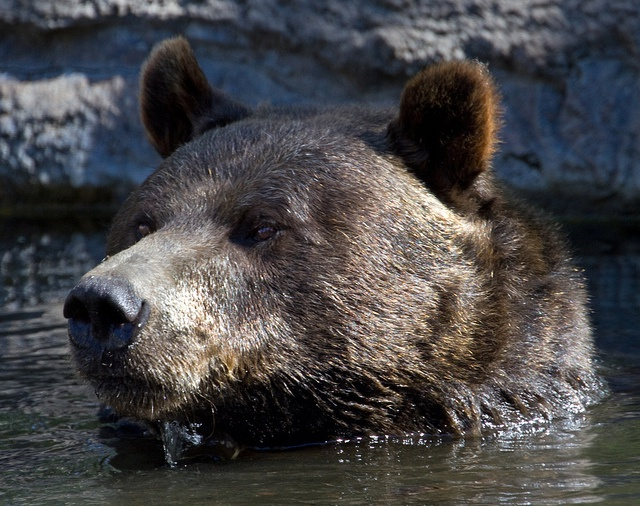Describe the objects in this image and their specific colors. I can see a bear in gray, black, and darkgray tones in this image. 